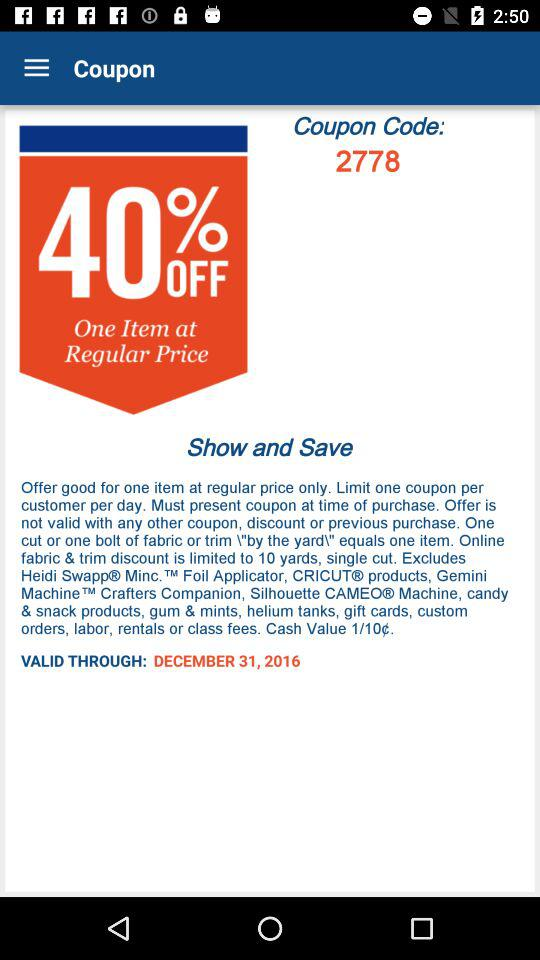How long is the validity? The validity is valid until December 31, 2016. 